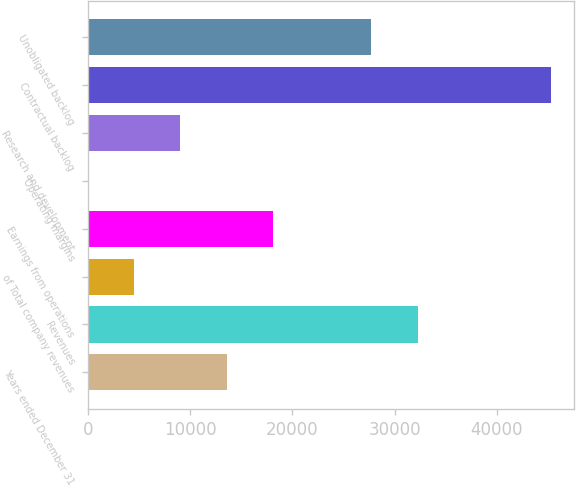Convert chart to OTSL. <chart><loc_0><loc_0><loc_500><loc_500><bar_chart><fcel>Years ended December 31<fcel>Revenues<fcel>of Total company revenues<fcel>Earnings from operations<fcel>Operating margins<fcel>Research and development<fcel>Contractual backlog<fcel>Unobligated backlog<nl><fcel>13592.6<fcel>32246.5<fcel>4537.59<fcel>18120.1<fcel>10.1<fcel>9065.08<fcel>45285<fcel>27719<nl></chart> 